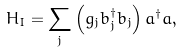Convert formula to latex. <formula><loc_0><loc_0><loc_500><loc_500>H _ { I } = \sum _ { j } \left ( g _ { j } b _ { j } ^ { \dagger } b _ { j } \right ) a ^ { \dagger } a ,</formula> 